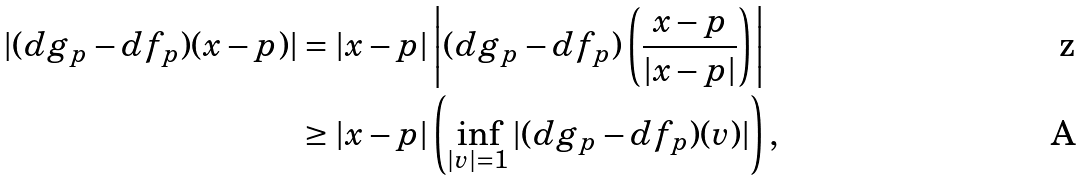Convert formula to latex. <formula><loc_0><loc_0><loc_500><loc_500>| ( d g _ { p } - d f _ { p } ) ( x - p ) | & = | x - p | \left | ( d g _ { p } - d f _ { p } ) \left ( \frac { x - p } { | x - p | } \right ) \right | \\ & \geq | x - p | \left ( \inf _ { | v | = 1 } | ( d g _ { p } - d f _ { p } ) ( v ) | \right ) ,</formula> 